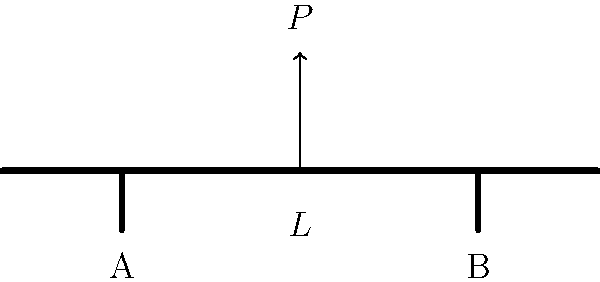In a bridge of witty proportions, we've got a load $P$ playing balancing act at the center. If we move one support to create a cantilever effect, how might the reaction at the remaining support change? Express your answer as a pun-ctual fraction of $P$. Let's break this down step-by-step, with a dash of humor:

1) Initially, we have a simply supported beam with two supports (A and B) and a center load $P$. The reactions are equally distributed:

   $R_A = R_B = \frac{P}{2}$

2) Now, if we remove support B (let's say it went on a "structural vacation"), we're left with a cantilever situation.

3) For a cantilever beam with a load at the free end:

   $R_A = P$ and $M_A = P \cdot L$

   Where $L$ is the full length of the beam.

4) In our case, the load is at the center, so the moment arm is $\frac{L}{2}$:

   $R_A = P$ and $M_A = P \cdot \frac{L}{2}$

5) The reaction at A has doubled from $\frac{P}{2}$ to $P$.

6) To express this change as a fraction of $P$:

   $\frac{\text{New Reaction}}{\text{Old Reaction}} = \frac{P}{\frac{P}{2}} = 2$

So, the reaction at the remaining support has doubled, or increased by a factor of 2.
Answer: $2P$ 